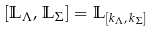Convert formula to latex. <formula><loc_0><loc_0><loc_500><loc_500>\left [ \mathbb { L } _ { \Lambda } , \, \mathbb { L } _ { \Sigma } \right ] = \mathbb { L } _ { [ k _ { \Lambda } , \, k _ { \Sigma } ] }</formula> 